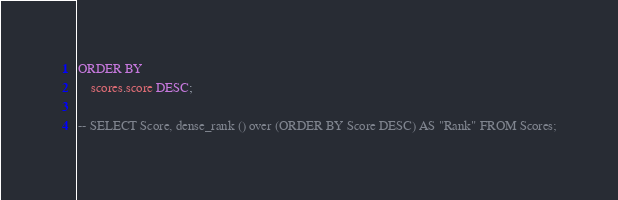Convert code to text. <code><loc_0><loc_0><loc_500><loc_500><_SQL_>ORDER BY
    scores.score DESC;

-- SELECT Score, dense_rank () over (ORDER BY Score DESC) AS "Rank" FROM Scores;
</code> 